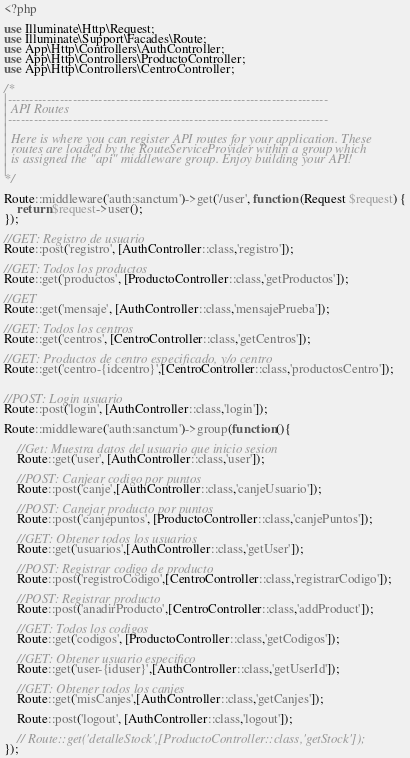<code> <loc_0><loc_0><loc_500><loc_500><_PHP_><?php

use Illuminate\Http\Request;
use Illuminate\Support\Facades\Route;
use App\Http\Controllers\AuthController;
use App\Http\Controllers\ProductoController;
use App\Http\Controllers\CentroController;

/*
|--------------------------------------------------------------------------
| API Routes
|--------------------------------------------------------------------------
|
| Here is where you can register API routes for your application. These
| routes are loaded by the RouteServiceProvider within a group which
| is assigned the "api" middleware group. Enjoy building your API!
|
*/

Route::middleware('auth:sanctum')->get('/user', function (Request $request) {
    return $request->user();
});

//GET: Registro de usuario
Route::post('registro', [AuthController::class,'registro']);

//GET: Todos los productos
Route::get('productos', [ProductoController::class,'getProductos']);

//GET
Route::get('mensaje', [AuthController::class,'mensajePrueba']);

//GET: Todos los centros
Route::get('centros', [CentroController::class,'getCentros']);

//GET: Productos de centro especificado, y/o centro
Route::get('centro-{idcentro}',[CentroController::class,'productosCentro']);


//POST: Login usuario
Route::post('login', [AuthController::class,'login']);

Route::middleware('auth:sanctum')->group(function(){

    //Get: Muestra datos del usuario que inicio sesion
    Route::get('user', [AuthController::class,'user']);

    //POST: Canjear codigo por puntos
    Route::post('canje',[AuthController::class,'canjeUsuario']);

    //POST: Canejar producto por puntos
    Route::post('canjepuntos', [ProductoController::class,'canjePuntos']);

    //GET: Obtener todos los usuarios
    Route::get('usuarios',[AuthController::class,'getUser']);

    //POST: Registrar codigo de producto
    Route::post('registroCodigo',[CentroController::class,'registrarCodigo']);

    //POST: Registrar producto
    Route::post('anadirProducto',[CentroController::class,'addProduct']);

    //GET: Todos los codigos
    Route::get('codigos', [ProductoController::class,'getCodigos']);

    //GET: Obtener usuario especifico
    Route::get('user-{iduser}',[AuthController::class,'getUserId']);

    //GET: Obtener todos los canjes
    Route::get('misCanjes',[AuthController::class,'getCanjes']);

    Route::post('logout', [AuthController::class,'logout']);

    // Route::get('detalleStock',[ProductoController::class,'getStock']);
});</code> 